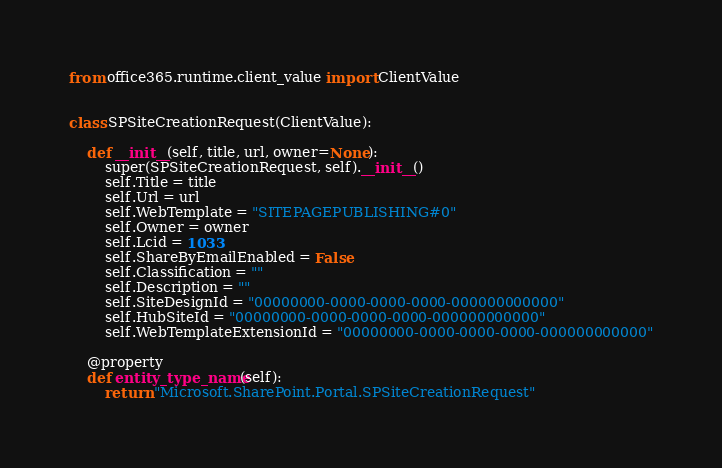Convert code to text. <code><loc_0><loc_0><loc_500><loc_500><_Python_>from office365.runtime.client_value import ClientValue


class SPSiteCreationRequest(ClientValue):

    def __init__(self, title, url, owner=None):
        super(SPSiteCreationRequest, self).__init__()
        self.Title = title
        self.Url = url
        self.WebTemplate = "SITEPAGEPUBLISHING#0"
        self.Owner = owner
        self.Lcid = 1033
        self.ShareByEmailEnabled = False
        self.Classification = ""
        self.Description = ""
        self.SiteDesignId = "00000000-0000-0000-0000-000000000000"
        self.HubSiteId = "00000000-0000-0000-0000-000000000000"
        self.WebTemplateExtensionId = "00000000-0000-0000-0000-000000000000"

    @property
    def entity_type_name(self):
        return "Microsoft.SharePoint.Portal.SPSiteCreationRequest"
</code> 